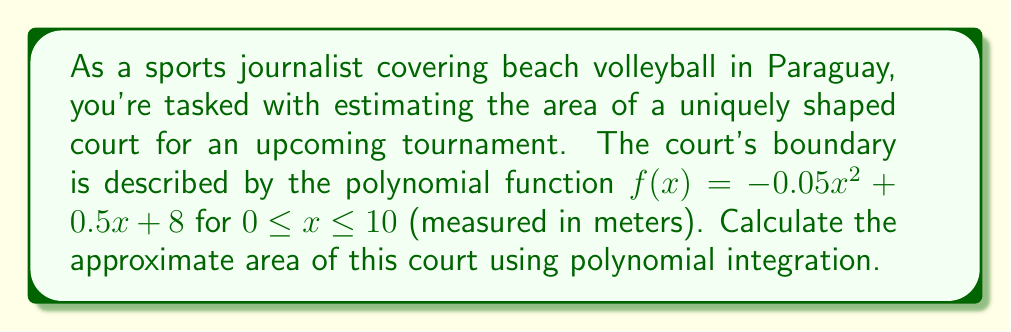Teach me how to tackle this problem. To find the area of the court, we need to integrate the function $f(x)$ over the given interval. The area is given by the definite integral:

$$A = \int_{0}^{10} f(x) dx = \int_{0}^{10} (-0.05x^2 + 0.5x + 8) dx$$

Let's integrate this polynomial term by term:

1) $\int -0.05x^2 dx = -0.05 \cdot \frac{x^3}{3} + C$
2) $\int 0.5x dx = 0.5 \cdot \frac{x^2}{2} + C = 0.25x^2 + C$
3) $\int 8 dx = 8x + C$

Now, we can write the indefinite integral:

$$\int f(x) dx = -\frac{0.05x^3}{3} + 0.25x^2 + 8x + C$$

To find the definite integral, we evaluate this at the upper and lower limits and subtract:

$$A = \left[-\frac{0.05x^3}{3} + 0.25x^2 + 8x\right]_{0}^{10}$$

$$= \left(-\frac{0.05(10^3)}{3} + 0.25(10^2) + 8(10)\right) - \left(-\frac{0.05(0^3)}{3} + 0.25(0^2) + 8(0)\right)$$

$$= (-16.67 + 25 + 80) - (0)$$

$$= 88.33$$

Therefore, the approximate area of the beach volleyball court is 88.33 square meters.
Answer: 88.33 square meters 